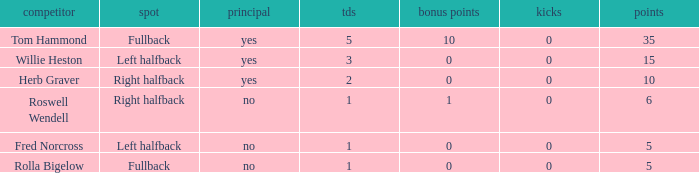What is the lowest number of touchdowns for left halfback WIllie Heston who has more than 15 points? None. 